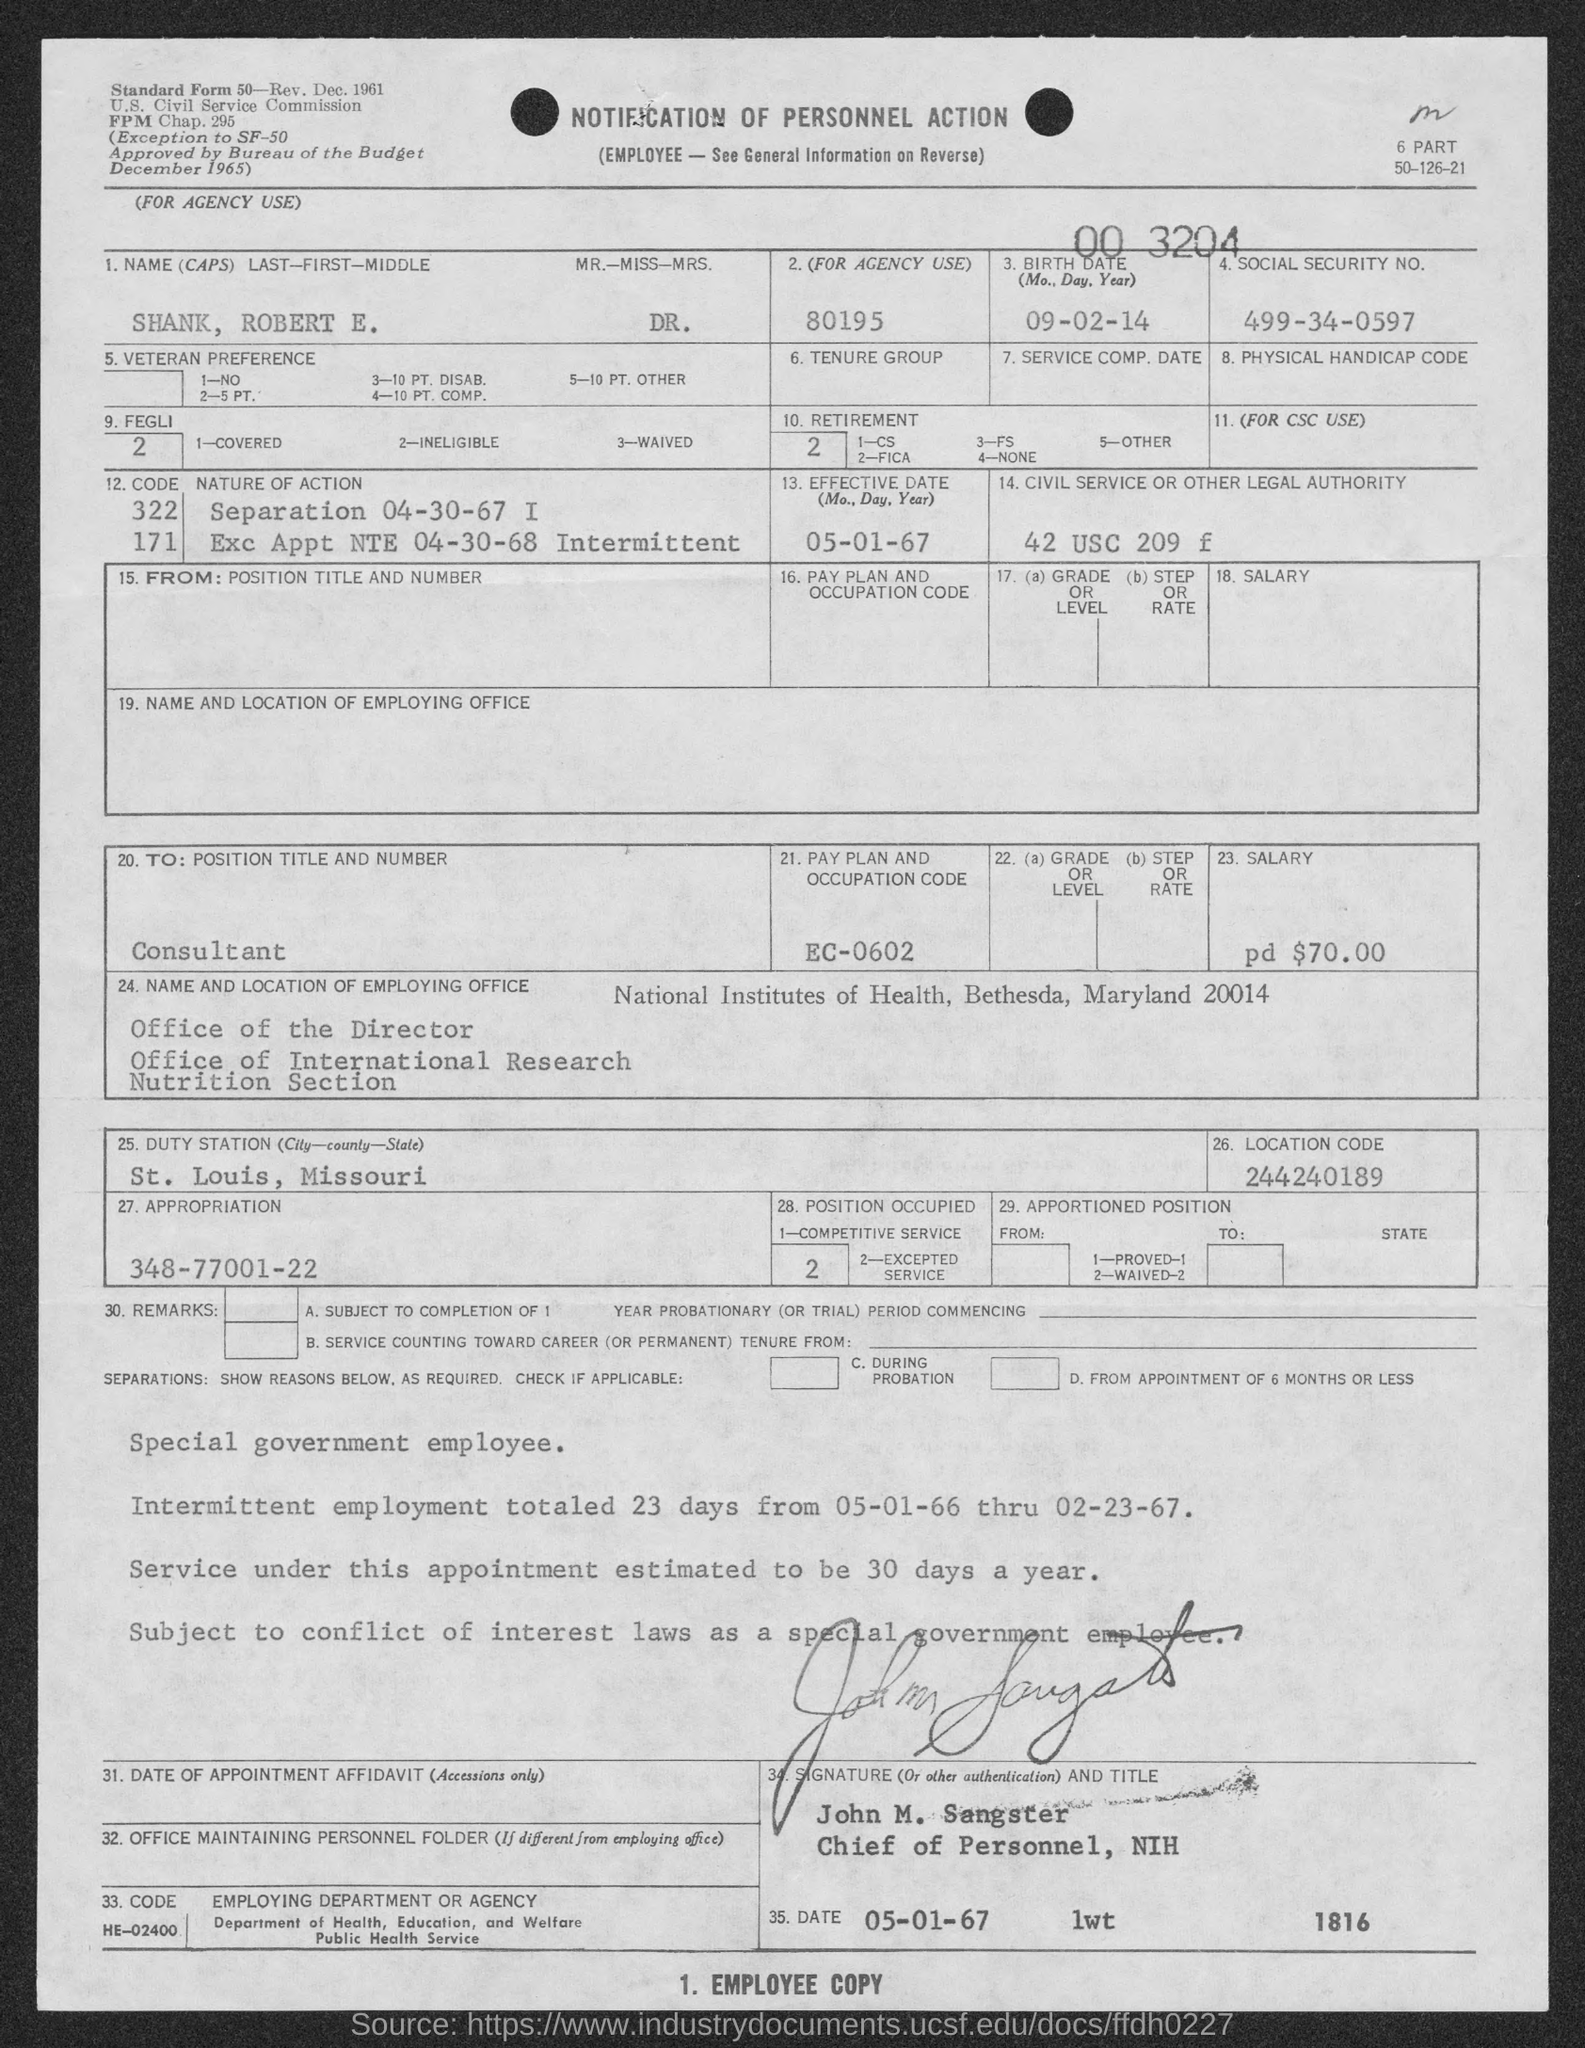What is the notification about?
Give a very brief answer. Notification of Personnel Action. What is written at bottom of page?
Offer a terse response. 1. EMPLOYEE COPY. Who is the chief of personnel, nih ?
Make the answer very short. John M. Sangster. What is pay plan and occupation code ?
Make the answer very short. EC-0602. What is the date on which the document is signed ?
Your response must be concise. 05-01-67. 